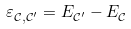<formula> <loc_0><loc_0><loc_500><loc_500>\varepsilon ^ { \ } _ { \mathcal { C } , \mathcal { C } ^ { \prime } } = E ^ { \ } _ { \mathcal { C } ^ { \prime } } - E ^ { \ } _ { \mathcal { C } }</formula> 